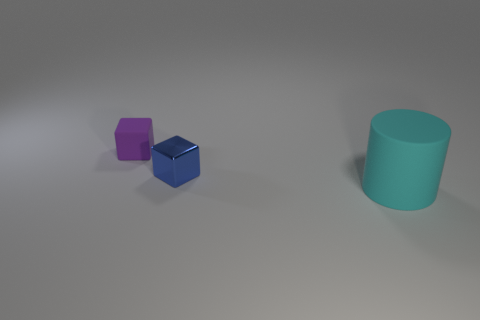There is a cube that is to the left of the blue shiny block; how big is it?
Provide a short and direct response. Small. Do the purple object and the big cylinder have the same material?
Keep it short and to the point. Yes. Is there a metallic block that is on the left side of the tiny cube that is behind the cube that is to the right of the purple rubber thing?
Make the answer very short. No. What color is the metal block?
Offer a very short reply. Blue. There is another block that is the same size as the blue shiny cube; what is its color?
Your response must be concise. Purple. There is a tiny thing in front of the purple thing; is its shape the same as the small purple rubber object?
Your answer should be very brief. Yes. There is a rubber thing that is behind the cube that is in front of the small thing on the left side of the blue thing; what is its color?
Your response must be concise. Purple. Are any cyan things visible?
Keep it short and to the point. Yes. What number of other things are there of the same size as the purple rubber block?
Provide a succinct answer. 1. How many objects are cubes or big rubber objects?
Your response must be concise. 3. 